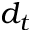Convert formula to latex. <formula><loc_0><loc_0><loc_500><loc_500>d _ { t }</formula> 